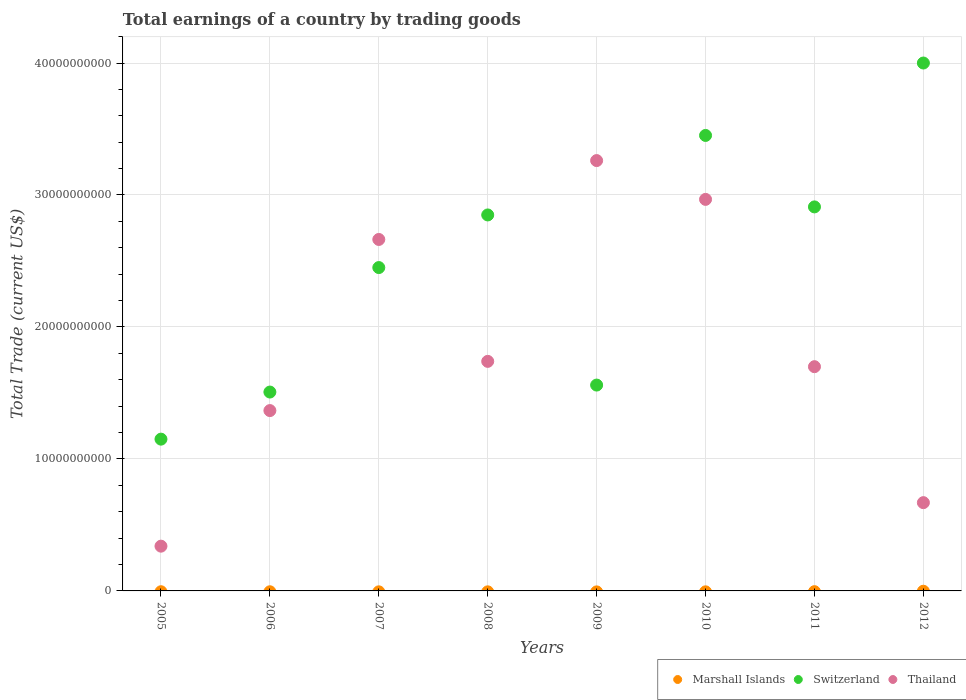How many different coloured dotlines are there?
Your answer should be compact. 2. What is the total earnings in Thailand in 2008?
Provide a short and direct response. 1.74e+1. Across all years, what is the maximum total earnings in Switzerland?
Keep it short and to the point. 4.00e+1. Across all years, what is the minimum total earnings in Thailand?
Give a very brief answer. 3.39e+09. What is the total total earnings in Thailand in the graph?
Ensure brevity in your answer.  1.47e+11. What is the difference between the total earnings in Switzerland in 2006 and that in 2008?
Provide a short and direct response. -1.34e+1. What is the difference between the total earnings in Switzerland in 2011 and the total earnings in Marshall Islands in 2008?
Provide a short and direct response. 2.91e+1. What is the average total earnings in Marshall Islands per year?
Make the answer very short. 0. In the year 2011, what is the difference between the total earnings in Switzerland and total earnings in Thailand?
Offer a terse response. 1.21e+1. What is the ratio of the total earnings in Thailand in 2009 to that in 2010?
Keep it short and to the point. 1.1. Is the total earnings in Thailand in 2006 less than that in 2010?
Give a very brief answer. Yes. What is the difference between the highest and the second highest total earnings in Switzerland?
Your response must be concise. 5.49e+09. What is the difference between the highest and the lowest total earnings in Switzerland?
Offer a terse response. 2.85e+1. In how many years, is the total earnings in Thailand greater than the average total earnings in Thailand taken over all years?
Provide a short and direct response. 3. Is the sum of the total earnings in Switzerland in 2010 and 2012 greater than the maximum total earnings in Thailand across all years?
Your response must be concise. Yes. Does the total earnings in Switzerland monotonically increase over the years?
Provide a short and direct response. No. How many years are there in the graph?
Ensure brevity in your answer.  8. What is the difference between two consecutive major ticks on the Y-axis?
Make the answer very short. 1.00e+1. Are the values on the major ticks of Y-axis written in scientific E-notation?
Ensure brevity in your answer.  No. Does the graph contain any zero values?
Keep it short and to the point. Yes. Does the graph contain grids?
Provide a succinct answer. Yes. How are the legend labels stacked?
Provide a short and direct response. Horizontal. What is the title of the graph?
Offer a very short reply. Total earnings of a country by trading goods. Does "France" appear as one of the legend labels in the graph?
Provide a short and direct response. No. What is the label or title of the Y-axis?
Offer a terse response. Total Trade (current US$). What is the Total Trade (current US$) in Marshall Islands in 2005?
Make the answer very short. 0. What is the Total Trade (current US$) of Switzerland in 2005?
Provide a succinct answer. 1.15e+1. What is the Total Trade (current US$) of Thailand in 2005?
Give a very brief answer. 3.39e+09. What is the Total Trade (current US$) in Marshall Islands in 2006?
Make the answer very short. 0. What is the Total Trade (current US$) of Switzerland in 2006?
Provide a short and direct response. 1.51e+1. What is the Total Trade (current US$) in Thailand in 2006?
Ensure brevity in your answer.  1.37e+1. What is the Total Trade (current US$) in Switzerland in 2007?
Give a very brief answer. 2.45e+1. What is the Total Trade (current US$) of Thailand in 2007?
Ensure brevity in your answer.  2.66e+1. What is the Total Trade (current US$) in Switzerland in 2008?
Your response must be concise. 2.85e+1. What is the Total Trade (current US$) in Thailand in 2008?
Your answer should be compact. 1.74e+1. What is the Total Trade (current US$) of Marshall Islands in 2009?
Provide a short and direct response. 0. What is the Total Trade (current US$) of Switzerland in 2009?
Ensure brevity in your answer.  1.56e+1. What is the Total Trade (current US$) in Thailand in 2009?
Give a very brief answer. 3.26e+1. What is the Total Trade (current US$) in Marshall Islands in 2010?
Give a very brief answer. 0. What is the Total Trade (current US$) in Switzerland in 2010?
Your response must be concise. 3.45e+1. What is the Total Trade (current US$) in Thailand in 2010?
Provide a short and direct response. 2.97e+1. What is the Total Trade (current US$) of Marshall Islands in 2011?
Ensure brevity in your answer.  0. What is the Total Trade (current US$) in Switzerland in 2011?
Offer a terse response. 2.91e+1. What is the Total Trade (current US$) in Thailand in 2011?
Provide a succinct answer. 1.70e+1. What is the Total Trade (current US$) of Switzerland in 2012?
Provide a short and direct response. 4.00e+1. What is the Total Trade (current US$) of Thailand in 2012?
Your answer should be very brief. 6.69e+09. Across all years, what is the maximum Total Trade (current US$) in Switzerland?
Your answer should be very brief. 4.00e+1. Across all years, what is the maximum Total Trade (current US$) in Thailand?
Offer a terse response. 3.26e+1. Across all years, what is the minimum Total Trade (current US$) of Switzerland?
Provide a succinct answer. 1.15e+1. Across all years, what is the minimum Total Trade (current US$) of Thailand?
Provide a succinct answer. 3.39e+09. What is the total Total Trade (current US$) of Switzerland in the graph?
Ensure brevity in your answer.  1.99e+11. What is the total Total Trade (current US$) in Thailand in the graph?
Offer a terse response. 1.47e+11. What is the difference between the Total Trade (current US$) in Switzerland in 2005 and that in 2006?
Ensure brevity in your answer.  -3.57e+09. What is the difference between the Total Trade (current US$) of Thailand in 2005 and that in 2006?
Offer a very short reply. -1.03e+1. What is the difference between the Total Trade (current US$) in Switzerland in 2005 and that in 2007?
Your answer should be compact. -1.30e+1. What is the difference between the Total Trade (current US$) of Thailand in 2005 and that in 2007?
Your answer should be compact. -2.32e+1. What is the difference between the Total Trade (current US$) of Switzerland in 2005 and that in 2008?
Give a very brief answer. -1.70e+1. What is the difference between the Total Trade (current US$) of Thailand in 2005 and that in 2008?
Offer a very short reply. -1.40e+1. What is the difference between the Total Trade (current US$) of Switzerland in 2005 and that in 2009?
Provide a succinct answer. -4.10e+09. What is the difference between the Total Trade (current US$) of Thailand in 2005 and that in 2009?
Ensure brevity in your answer.  -2.92e+1. What is the difference between the Total Trade (current US$) in Switzerland in 2005 and that in 2010?
Offer a very short reply. -2.30e+1. What is the difference between the Total Trade (current US$) in Thailand in 2005 and that in 2010?
Your answer should be very brief. -2.63e+1. What is the difference between the Total Trade (current US$) of Switzerland in 2005 and that in 2011?
Offer a terse response. -1.76e+1. What is the difference between the Total Trade (current US$) in Thailand in 2005 and that in 2011?
Your answer should be compact. -1.36e+1. What is the difference between the Total Trade (current US$) of Switzerland in 2005 and that in 2012?
Your answer should be compact. -2.85e+1. What is the difference between the Total Trade (current US$) of Thailand in 2005 and that in 2012?
Keep it short and to the point. -3.30e+09. What is the difference between the Total Trade (current US$) in Switzerland in 2006 and that in 2007?
Offer a very short reply. -9.43e+09. What is the difference between the Total Trade (current US$) in Thailand in 2006 and that in 2007?
Give a very brief answer. -1.30e+1. What is the difference between the Total Trade (current US$) in Switzerland in 2006 and that in 2008?
Provide a succinct answer. -1.34e+1. What is the difference between the Total Trade (current US$) of Thailand in 2006 and that in 2008?
Provide a short and direct response. -3.73e+09. What is the difference between the Total Trade (current US$) in Switzerland in 2006 and that in 2009?
Your answer should be very brief. -5.28e+08. What is the difference between the Total Trade (current US$) in Thailand in 2006 and that in 2009?
Provide a succinct answer. -1.89e+1. What is the difference between the Total Trade (current US$) of Switzerland in 2006 and that in 2010?
Provide a succinct answer. -1.94e+1. What is the difference between the Total Trade (current US$) in Thailand in 2006 and that in 2010?
Keep it short and to the point. -1.60e+1. What is the difference between the Total Trade (current US$) of Switzerland in 2006 and that in 2011?
Keep it short and to the point. -1.40e+1. What is the difference between the Total Trade (current US$) of Thailand in 2006 and that in 2011?
Your response must be concise. -3.33e+09. What is the difference between the Total Trade (current US$) in Switzerland in 2006 and that in 2012?
Provide a short and direct response. -2.49e+1. What is the difference between the Total Trade (current US$) of Thailand in 2006 and that in 2012?
Ensure brevity in your answer.  6.98e+09. What is the difference between the Total Trade (current US$) of Switzerland in 2007 and that in 2008?
Make the answer very short. -3.99e+09. What is the difference between the Total Trade (current US$) in Thailand in 2007 and that in 2008?
Offer a terse response. 9.24e+09. What is the difference between the Total Trade (current US$) in Switzerland in 2007 and that in 2009?
Offer a very short reply. 8.90e+09. What is the difference between the Total Trade (current US$) of Thailand in 2007 and that in 2009?
Give a very brief answer. -5.98e+09. What is the difference between the Total Trade (current US$) of Switzerland in 2007 and that in 2010?
Your answer should be compact. -1.00e+1. What is the difference between the Total Trade (current US$) in Thailand in 2007 and that in 2010?
Ensure brevity in your answer.  -3.04e+09. What is the difference between the Total Trade (current US$) in Switzerland in 2007 and that in 2011?
Your answer should be compact. -4.60e+09. What is the difference between the Total Trade (current US$) in Thailand in 2007 and that in 2011?
Give a very brief answer. 9.64e+09. What is the difference between the Total Trade (current US$) in Switzerland in 2007 and that in 2012?
Provide a short and direct response. -1.55e+1. What is the difference between the Total Trade (current US$) in Thailand in 2007 and that in 2012?
Make the answer very short. 1.99e+1. What is the difference between the Total Trade (current US$) of Switzerland in 2008 and that in 2009?
Give a very brief answer. 1.29e+1. What is the difference between the Total Trade (current US$) in Thailand in 2008 and that in 2009?
Your response must be concise. -1.52e+1. What is the difference between the Total Trade (current US$) in Switzerland in 2008 and that in 2010?
Provide a succinct answer. -6.02e+09. What is the difference between the Total Trade (current US$) in Thailand in 2008 and that in 2010?
Your answer should be very brief. -1.23e+1. What is the difference between the Total Trade (current US$) in Switzerland in 2008 and that in 2011?
Your response must be concise. -6.10e+08. What is the difference between the Total Trade (current US$) in Thailand in 2008 and that in 2011?
Your answer should be compact. 4.03e+08. What is the difference between the Total Trade (current US$) in Switzerland in 2008 and that in 2012?
Your answer should be very brief. -1.15e+1. What is the difference between the Total Trade (current US$) in Thailand in 2008 and that in 2012?
Give a very brief answer. 1.07e+1. What is the difference between the Total Trade (current US$) of Switzerland in 2009 and that in 2010?
Ensure brevity in your answer.  -1.89e+1. What is the difference between the Total Trade (current US$) in Thailand in 2009 and that in 2010?
Your answer should be compact. 2.94e+09. What is the difference between the Total Trade (current US$) of Switzerland in 2009 and that in 2011?
Make the answer very short. -1.35e+1. What is the difference between the Total Trade (current US$) in Thailand in 2009 and that in 2011?
Ensure brevity in your answer.  1.56e+1. What is the difference between the Total Trade (current US$) in Switzerland in 2009 and that in 2012?
Your response must be concise. -2.44e+1. What is the difference between the Total Trade (current US$) of Thailand in 2009 and that in 2012?
Give a very brief answer. 2.59e+1. What is the difference between the Total Trade (current US$) of Switzerland in 2010 and that in 2011?
Give a very brief answer. 5.41e+09. What is the difference between the Total Trade (current US$) in Thailand in 2010 and that in 2011?
Make the answer very short. 1.27e+1. What is the difference between the Total Trade (current US$) in Switzerland in 2010 and that in 2012?
Offer a terse response. -5.49e+09. What is the difference between the Total Trade (current US$) of Thailand in 2010 and that in 2012?
Your answer should be very brief. 2.30e+1. What is the difference between the Total Trade (current US$) in Switzerland in 2011 and that in 2012?
Keep it short and to the point. -1.09e+1. What is the difference between the Total Trade (current US$) in Thailand in 2011 and that in 2012?
Offer a terse response. 1.03e+1. What is the difference between the Total Trade (current US$) in Switzerland in 2005 and the Total Trade (current US$) in Thailand in 2006?
Your response must be concise. -2.16e+09. What is the difference between the Total Trade (current US$) of Switzerland in 2005 and the Total Trade (current US$) of Thailand in 2007?
Ensure brevity in your answer.  -1.51e+1. What is the difference between the Total Trade (current US$) of Switzerland in 2005 and the Total Trade (current US$) of Thailand in 2008?
Ensure brevity in your answer.  -5.89e+09. What is the difference between the Total Trade (current US$) in Switzerland in 2005 and the Total Trade (current US$) in Thailand in 2009?
Provide a succinct answer. -2.11e+1. What is the difference between the Total Trade (current US$) in Switzerland in 2005 and the Total Trade (current US$) in Thailand in 2010?
Provide a short and direct response. -1.82e+1. What is the difference between the Total Trade (current US$) in Switzerland in 2005 and the Total Trade (current US$) in Thailand in 2011?
Ensure brevity in your answer.  -5.49e+09. What is the difference between the Total Trade (current US$) of Switzerland in 2005 and the Total Trade (current US$) of Thailand in 2012?
Ensure brevity in your answer.  4.81e+09. What is the difference between the Total Trade (current US$) in Switzerland in 2006 and the Total Trade (current US$) in Thailand in 2007?
Your response must be concise. -1.16e+1. What is the difference between the Total Trade (current US$) of Switzerland in 2006 and the Total Trade (current US$) of Thailand in 2008?
Your answer should be compact. -2.33e+09. What is the difference between the Total Trade (current US$) of Switzerland in 2006 and the Total Trade (current US$) of Thailand in 2009?
Make the answer very short. -1.75e+1. What is the difference between the Total Trade (current US$) of Switzerland in 2006 and the Total Trade (current US$) of Thailand in 2010?
Your answer should be compact. -1.46e+1. What is the difference between the Total Trade (current US$) in Switzerland in 2006 and the Total Trade (current US$) in Thailand in 2011?
Give a very brief answer. -1.92e+09. What is the difference between the Total Trade (current US$) of Switzerland in 2006 and the Total Trade (current US$) of Thailand in 2012?
Provide a short and direct response. 8.38e+09. What is the difference between the Total Trade (current US$) in Switzerland in 2007 and the Total Trade (current US$) in Thailand in 2008?
Offer a terse response. 7.11e+09. What is the difference between the Total Trade (current US$) of Switzerland in 2007 and the Total Trade (current US$) of Thailand in 2009?
Your answer should be very brief. -8.11e+09. What is the difference between the Total Trade (current US$) of Switzerland in 2007 and the Total Trade (current US$) of Thailand in 2010?
Give a very brief answer. -5.17e+09. What is the difference between the Total Trade (current US$) of Switzerland in 2007 and the Total Trade (current US$) of Thailand in 2011?
Offer a very short reply. 7.51e+09. What is the difference between the Total Trade (current US$) of Switzerland in 2007 and the Total Trade (current US$) of Thailand in 2012?
Your answer should be very brief. 1.78e+1. What is the difference between the Total Trade (current US$) of Switzerland in 2008 and the Total Trade (current US$) of Thailand in 2009?
Ensure brevity in your answer.  -4.12e+09. What is the difference between the Total Trade (current US$) in Switzerland in 2008 and the Total Trade (current US$) in Thailand in 2010?
Provide a succinct answer. -1.18e+09. What is the difference between the Total Trade (current US$) of Switzerland in 2008 and the Total Trade (current US$) of Thailand in 2011?
Your response must be concise. 1.15e+1. What is the difference between the Total Trade (current US$) of Switzerland in 2008 and the Total Trade (current US$) of Thailand in 2012?
Your answer should be very brief. 2.18e+1. What is the difference between the Total Trade (current US$) of Switzerland in 2009 and the Total Trade (current US$) of Thailand in 2010?
Provide a short and direct response. -1.41e+1. What is the difference between the Total Trade (current US$) in Switzerland in 2009 and the Total Trade (current US$) in Thailand in 2011?
Your answer should be compact. -1.39e+09. What is the difference between the Total Trade (current US$) of Switzerland in 2009 and the Total Trade (current US$) of Thailand in 2012?
Your answer should be compact. 8.91e+09. What is the difference between the Total Trade (current US$) in Switzerland in 2010 and the Total Trade (current US$) in Thailand in 2011?
Keep it short and to the point. 1.75e+1. What is the difference between the Total Trade (current US$) in Switzerland in 2010 and the Total Trade (current US$) in Thailand in 2012?
Make the answer very short. 2.78e+1. What is the difference between the Total Trade (current US$) of Switzerland in 2011 and the Total Trade (current US$) of Thailand in 2012?
Make the answer very short. 2.24e+1. What is the average Total Trade (current US$) of Marshall Islands per year?
Offer a very short reply. 0. What is the average Total Trade (current US$) in Switzerland per year?
Provide a short and direct response. 2.48e+1. What is the average Total Trade (current US$) in Thailand per year?
Your response must be concise. 1.84e+1. In the year 2005, what is the difference between the Total Trade (current US$) of Switzerland and Total Trade (current US$) of Thailand?
Provide a succinct answer. 8.11e+09. In the year 2006, what is the difference between the Total Trade (current US$) in Switzerland and Total Trade (current US$) in Thailand?
Your answer should be compact. 1.40e+09. In the year 2007, what is the difference between the Total Trade (current US$) of Switzerland and Total Trade (current US$) of Thailand?
Your answer should be compact. -2.13e+09. In the year 2008, what is the difference between the Total Trade (current US$) of Switzerland and Total Trade (current US$) of Thailand?
Make the answer very short. 1.11e+1. In the year 2009, what is the difference between the Total Trade (current US$) in Switzerland and Total Trade (current US$) in Thailand?
Make the answer very short. -1.70e+1. In the year 2010, what is the difference between the Total Trade (current US$) in Switzerland and Total Trade (current US$) in Thailand?
Your answer should be very brief. 4.84e+09. In the year 2011, what is the difference between the Total Trade (current US$) of Switzerland and Total Trade (current US$) of Thailand?
Your answer should be compact. 1.21e+1. In the year 2012, what is the difference between the Total Trade (current US$) of Switzerland and Total Trade (current US$) of Thailand?
Your response must be concise. 3.33e+1. What is the ratio of the Total Trade (current US$) of Switzerland in 2005 to that in 2006?
Provide a succinct answer. 0.76. What is the ratio of the Total Trade (current US$) of Thailand in 2005 to that in 2006?
Offer a very short reply. 0.25. What is the ratio of the Total Trade (current US$) in Switzerland in 2005 to that in 2007?
Offer a very short reply. 0.47. What is the ratio of the Total Trade (current US$) in Thailand in 2005 to that in 2007?
Keep it short and to the point. 0.13. What is the ratio of the Total Trade (current US$) in Switzerland in 2005 to that in 2008?
Provide a short and direct response. 0.4. What is the ratio of the Total Trade (current US$) in Thailand in 2005 to that in 2008?
Ensure brevity in your answer.  0.2. What is the ratio of the Total Trade (current US$) of Switzerland in 2005 to that in 2009?
Offer a very short reply. 0.74. What is the ratio of the Total Trade (current US$) of Thailand in 2005 to that in 2009?
Provide a short and direct response. 0.1. What is the ratio of the Total Trade (current US$) of Switzerland in 2005 to that in 2010?
Give a very brief answer. 0.33. What is the ratio of the Total Trade (current US$) in Thailand in 2005 to that in 2010?
Make the answer very short. 0.11. What is the ratio of the Total Trade (current US$) of Switzerland in 2005 to that in 2011?
Keep it short and to the point. 0.4. What is the ratio of the Total Trade (current US$) of Thailand in 2005 to that in 2011?
Provide a succinct answer. 0.2. What is the ratio of the Total Trade (current US$) of Switzerland in 2005 to that in 2012?
Offer a very short reply. 0.29. What is the ratio of the Total Trade (current US$) in Thailand in 2005 to that in 2012?
Make the answer very short. 0.51. What is the ratio of the Total Trade (current US$) in Switzerland in 2006 to that in 2007?
Offer a terse response. 0.61. What is the ratio of the Total Trade (current US$) in Thailand in 2006 to that in 2007?
Your response must be concise. 0.51. What is the ratio of the Total Trade (current US$) in Switzerland in 2006 to that in 2008?
Keep it short and to the point. 0.53. What is the ratio of the Total Trade (current US$) in Thailand in 2006 to that in 2008?
Keep it short and to the point. 0.79. What is the ratio of the Total Trade (current US$) in Switzerland in 2006 to that in 2009?
Ensure brevity in your answer.  0.97. What is the ratio of the Total Trade (current US$) in Thailand in 2006 to that in 2009?
Your response must be concise. 0.42. What is the ratio of the Total Trade (current US$) of Switzerland in 2006 to that in 2010?
Offer a terse response. 0.44. What is the ratio of the Total Trade (current US$) of Thailand in 2006 to that in 2010?
Your answer should be compact. 0.46. What is the ratio of the Total Trade (current US$) in Switzerland in 2006 to that in 2011?
Your response must be concise. 0.52. What is the ratio of the Total Trade (current US$) in Thailand in 2006 to that in 2011?
Keep it short and to the point. 0.8. What is the ratio of the Total Trade (current US$) in Switzerland in 2006 to that in 2012?
Offer a very short reply. 0.38. What is the ratio of the Total Trade (current US$) of Thailand in 2006 to that in 2012?
Keep it short and to the point. 2.04. What is the ratio of the Total Trade (current US$) in Switzerland in 2007 to that in 2008?
Keep it short and to the point. 0.86. What is the ratio of the Total Trade (current US$) of Thailand in 2007 to that in 2008?
Your response must be concise. 1.53. What is the ratio of the Total Trade (current US$) in Switzerland in 2007 to that in 2009?
Offer a terse response. 1.57. What is the ratio of the Total Trade (current US$) in Thailand in 2007 to that in 2009?
Provide a succinct answer. 0.82. What is the ratio of the Total Trade (current US$) in Switzerland in 2007 to that in 2010?
Your response must be concise. 0.71. What is the ratio of the Total Trade (current US$) in Thailand in 2007 to that in 2010?
Give a very brief answer. 0.9. What is the ratio of the Total Trade (current US$) of Switzerland in 2007 to that in 2011?
Provide a short and direct response. 0.84. What is the ratio of the Total Trade (current US$) of Thailand in 2007 to that in 2011?
Your response must be concise. 1.57. What is the ratio of the Total Trade (current US$) in Switzerland in 2007 to that in 2012?
Give a very brief answer. 0.61. What is the ratio of the Total Trade (current US$) in Thailand in 2007 to that in 2012?
Make the answer very short. 3.98. What is the ratio of the Total Trade (current US$) of Switzerland in 2008 to that in 2009?
Your answer should be very brief. 1.83. What is the ratio of the Total Trade (current US$) of Thailand in 2008 to that in 2009?
Your answer should be very brief. 0.53. What is the ratio of the Total Trade (current US$) in Switzerland in 2008 to that in 2010?
Offer a terse response. 0.83. What is the ratio of the Total Trade (current US$) in Thailand in 2008 to that in 2010?
Provide a short and direct response. 0.59. What is the ratio of the Total Trade (current US$) of Thailand in 2008 to that in 2011?
Your answer should be compact. 1.02. What is the ratio of the Total Trade (current US$) in Switzerland in 2008 to that in 2012?
Your answer should be very brief. 0.71. What is the ratio of the Total Trade (current US$) in Thailand in 2008 to that in 2012?
Your answer should be compact. 2.6. What is the ratio of the Total Trade (current US$) in Switzerland in 2009 to that in 2010?
Provide a short and direct response. 0.45. What is the ratio of the Total Trade (current US$) of Thailand in 2009 to that in 2010?
Your response must be concise. 1.1. What is the ratio of the Total Trade (current US$) of Switzerland in 2009 to that in 2011?
Keep it short and to the point. 0.54. What is the ratio of the Total Trade (current US$) of Thailand in 2009 to that in 2011?
Keep it short and to the point. 1.92. What is the ratio of the Total Trade (current US$) of Switzerland in 2009 to that in 2012?
Ensure brevity in your answer.  0.39. What is the ratio of the Total Trade (current US$) of Thailand in 2009 to that in 2012?
Offer a terse response. 4.88. What is the ratio of the Total Trade (current US$) in Switzerland in 2010 to that in 2011?
Offer a terse response. 1.19. What is the ratio of the Total Trade (current US$) in Thailand in 2010 to that in 2011?
Your answer should be compact. 1.75. What is the ratio of the Total Trade (current US$) in Switzerland in 2010 to that in 2012?
Provide a succinct answer. 0.86. What is the ratio of the Total Trade (current US$) in Thailand in 2010 to that in 2012?
Offer a very short reply. 4.44. What is the ratio of the Total Trade (current US$) of Switzerland in 2011 to that in 2012?
Ensure brevity in your answer.  0.73. What is the ratio of the Total Trade (current US$) in Thailand in 2011 to that in 2012?
Offer a very short reply. 2.54. What is the difference between the highest and the second highest Total Trade (current US$) of Switzerland?
Your answer should be compact. 5.49e+09. What is the difference between the highest and the second highest Total Trade (current US$) of Thailand?
Offer a very short reply. 2.94e+09. What is the difference between the highest and the lowest Total Trade (current US$) of Switzerland?
Offer a terse response. 2.85e+1. What is the difference between the highest and the lowest Total Trade (current US$) of Thailand?
Keep it short and to the point. 2.92e+1. 